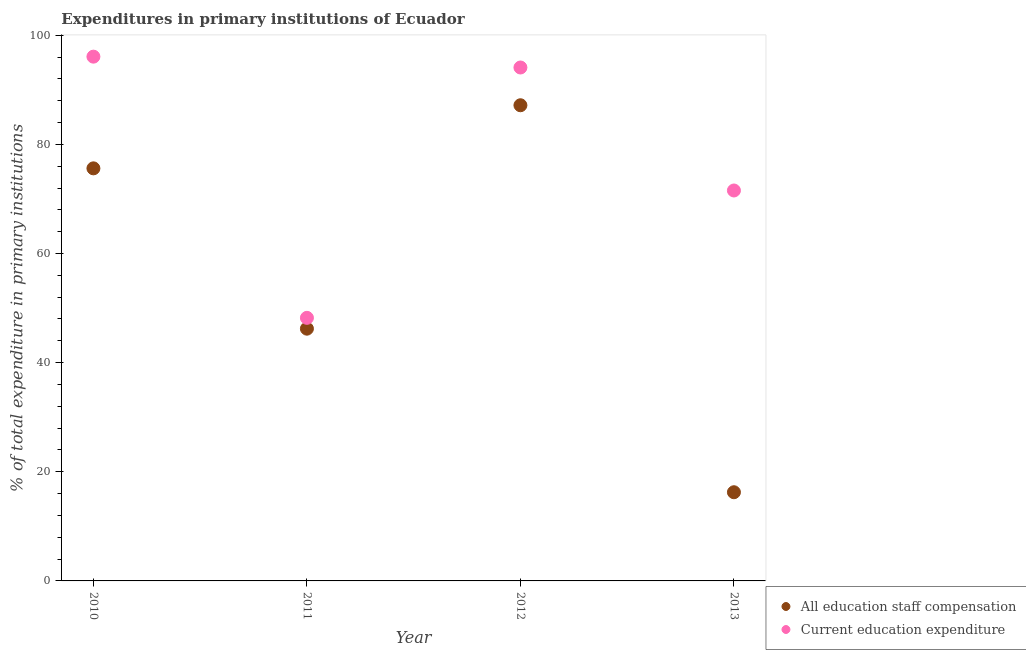How many different coloured dotlines are there?
Keep it short and to the point. 2. What is the expenditure in education in 2011?
Offer a very short reply. 48.21. Across all years, what is the maximum expenditure in education?
Your response must be concise. 96.07. Across all years, what is the minimum expenditure in staff compensation?
Offer a very short reply. 16.25. What is the total expenditure in staff compensation in the graph?
Offer a very short reply. 225.25. What is the difference between the expenditure in staff compensation in 2010 and that in 2011?
Provide a succinct answer. 29.38. What is the difference between the expenditure in staff compensation in 2011 and the expenditure in education in 2013?
Your answer should be compact. -25.32. What is the average expenditure in education per year?
Provide a short and direct response. 77.48. In the year 2013, what is the difference between the expenditure in education and expenditure in staff compensation?
Provide a short and direct response. 55.29. What is the ratio of the expenditure in staff compensation in 2010 to that in 2011?
Your answer should be very brief. 1.64. Is the difference between the expenditure in education in 2011 and 2012 greater than the difference between the expenditure in staff compensation in 2011 and 2012?
Provide a succinct answer. No. What is the difference between the highest and the second highest expenditure in staff compensation?
Ensure brevity in your answer.  11.56. What is the difference between the highest and the lowest expenditure in staff compensation?
Keep it short and to the point. 70.91. Does the expenditure in education monotonically increase over the years?
Make the answer very short. No. Is the expenditure in staff compensation strictly greater than the expenditure in education over the years?
Provide a succinct answer. No. Is the expenditure in education strictly less than the expenditure in staff compensation over the years?
Provide a succinct answer. No. How many years are there in the graph?
Keep it short and to the point. 4. What is the difference between two consecutive major ticks on the Y-axis?
Your answer should be compact. 20. Does the graph contain any zero values?
Your answer should be very brief. No. Does the graph contain grids?
Your response must be concise. No. What is the title of the graph?
Provide a succinct answer. Expenditures in primary institutions of Ecuador. Does "Age 65(female)" appear as one of the legend labels in the graph?
Your answer should be very brief. No. What is the label or title of the X-axis?
Your response must be concise. Year. What is the label or title of the Y-axis?
Your answer should be very brief. % of total expenditure in primary institutions. What is the % of total expenditure in primary institutions in All education staff compensation in 2010?
Give a very brief answer. 75.6. What is the % of total expenditure in primary institutions of Current education expenditure in 2010?
Ensure brevity in your answer.  96.07. What is the % of total expenditure in primary institutions in All education staff compensation in 2011?
Make the answer very short. 46.22. What is the % of total expenditure in primary institutions in Current education expenditure in 2011?
Give a very brief answer. 48.21. What is the % of total expenditure in primary institutions of All education staff compensation in 2012?
Give a very brief answer. 87.17. What is the % of total expenditure in primary institutions of Current education expenditure in 2012?
Provide a succinct answer. 94.08. What is the % of total expenditure in primary institutions in All education staff compensation in 2013?
Make the answer very short. 16.25. What is the % of total expenditure in primary institutions of Current education expenditure in 2013?
Provide a short and direct response. 71.55. Across all years, what is the maximum % of total expenditure in primary institutions of All education staff compensation?
Ensure brevity in your answer.  87.17. Across all years, what is the maximum % of total expenditure in primary institutions in Current education expenditure?
Your answer should be very brief. 96.07. Across all years, what is the minimum % of total expenditure in primary institutions of All education staff compensation?
Your answer should be very brief. 16.25. Across all years, what is the minimum % of total expenditure in primary institutions in Current education expenditure?
Your response must be concise. 48.21. What is the total % of total expenditure in primary institutions of All education staff compensation in the graph?
Provide a short and direct response. 225.25. What is the total % of total expenditure in primary institutions of Current education expenditure in the graph?
Ensure brevity in your answer.  309.91. What is the difference between the % of total expenditure in primary institutions of All education staff compensation in 2010 and that in 2011?
Make the answer very short. 29.38. What is the difference between the % of total expenditure in primary institutions in Current education expenditure in 2010 and that in 2011?
Your response must be concise. 47.86. What is the difference between the % of total expenditure in primary institutions of All education staff compensation in 2010 and that in 2012?
Make the answer very short. -11.56. What is the difference between the % of total expenditure in primary institutions in Current education expenditure in 2010 and that in 2012?
Your response must be concise. 1.99. What is the difference between the % of total expenditure in primary institutions in All education staff compensation in 2010 and that in 2013?
Give a very brief answer. 59.35. What is the difference between the % of total expenditure in primary institutions of Current education expenditure in 2010 and that in 2013?
Give a very brief answer. 24.52. What is the difference between the % of total expenditure in primary institutions in All education staff compensation in 2011 and that in 2012?
Make the answer very short. -40.94. What is the difference between the % of total expenditure in primary institutions in Current education expenditure in 2011 and that in 2012?
Offer a terse response. -45.87. What is the difference between the % of total expenditure in primary institutions of All education staff compensation in 2011 and that in 2013?
Offer a very short reply. 29.97. What is the difference between the % of total expenditure in primary institutions in Current education expenditure in 2011 and that in 2013?
Keep it short and to the point. -23.34. What is the difference between the % of total expenditure in primary institutions of All education staff compensation in 2012 and that in 2013?
Keep it short and to the point. 70.91. What is the difference between the % of total expenditure in primary institutions in Current education expenditure in 2012 and that in 2013?
Offer a terse response. 22.54. What is the difference between the % of total expenditure in primary institutions of All education staff compensation in 2010 and the % of total expenditure in primary institutions of Current education expenditure in 2011?
Provide a succinct answer. 27.39. What is the difference between the % of total expenditure in primary institutions in All education staff compensation in 2010 and the % of total expenditure in primary institutions in Current education expenditure in 2012?
Your answer should be compact. -18.48. What is the difference between the % of total expenditure in primary institutions of All education staff compensation in 2010 and the % of total expenditure in primary institutions of Current education expenditure in 2013?
Your answer should be compact. 4.06. What is the difference between the % of total expenditure in primary institutions of All education staff compensation in 2011 and the % of total expenditure in primary institutions of Current education expenditure in 2012?
Your response must be concise. -47.86. What is the difference between the % of total expenditure in primary institutions of All education staff compensation in 2011 and the % of total expenditure in primary institutions of Current education expenditure in 2013?
Your response must be concise. -25.32. What is the difference between the % of total expenditure in primary institutions of All education staff compensation in 2012 and the % of total expenditure in primary institutions of Current education expenditure in 2013?
Provide a short and direct response. 15.62. What is the average % of total expenditure in primary institutions in All education staff compensation per year?
Provide a short and direct response. 56.31. What is the average % of total expenditure in primary institutions in Current education expenditure per year?
Keep it short and to the point. 77.48. In the year 2010, what is the difference between the % of total expenditure in primary institutions in All education staff compensation and % of total expenditure in primary institutions in Current education expenditure?
Offer a very short reply. -20.47. In the year 2011, what is the difference between the % of total expenditure in primary institutions of All education staff compensation and % of total expenditure in primary institutions of Current education expenditure?
Keep it short and to the point. -1.99. In the year 2012, what is the difference between the % of total expenditure in primary institutions in All education staff compensation and % of total expenditure in primary institutions in Current education expenditure?
Make the answer very short. -6.92. In the year 2013, what is the difference between the % of total expenditure in primary institutions of All education staff compensation and % of total expenditure in primary institutions of Current education expenditure?
Your answer should be very brief. -55.29. What is the ratio of the % of total expenditure in primary institutions of All education staff compensation in 2010 to that in 2011?
Your answer should be compact. 1.64. What is the ratio of the % of total expenditure in primary institutions in Current education expenditure in 2010 to that in 2011?
Provide a succinct answer. 1.99. What is the ratio of the % of total expenditure in primary institutions of All education staff compensation in 2010 to that in 2012?
Keep it short and to the point. 0.87. What is the ratio of the % of total expenditure in primary institutions in Current education expenditure in 2010 to that in 2012?
Provide a short and direct response. 1.02. What is the ratio of the % of total expenditure in primary institutions in All education staff compensation in 2010 to that in 2013?
Offer a very short reply. 4.65. What is the ratio of the % of total expenditure in primary institutions in Current education expenditure in 2010 to that in 2013?
Give a very brief answer. 1.34. What is the ratio of the % of total expenditure in primary institutions of All education staff compensation in 2011 to that in 2012?
Provide a short and direct response. 0.53. What is the ratio of the % of total expenditure in primary institutions of Current education expenditure in 2011 to that in 2012?
Provide a succinct answer. 0.51. What is the ratio of the % of total expenditure in primary institutions in All education staff compensation in 2011 to that in 2013?
Ensure brevity in your answer.  2.84. What is the ratio of the % of total expenditure in primary institutions in Current education expenditure in 2011 to that in 2013?
Offer a terse response. 0.67. What is the ratio of the % of total expenditure in primary institutions of All education staff compensation in 2012 to that in 2013?
Offer a terse response. 5.36. What is the ratio of the % of total expenditure in primary institutions of Current education expenditure in 2012 to that in 2013?
Offer a terse response. 1.31. What is the difference between the highest and the second highest % of total expenditure in primary institutions of All education staff compensation?
Your answer should be very brief. 11.56. What is the difference between the highest and the second highest % of total expenditure in primary institutions of Current education expenditure?
Offer a terse response. 1.99. What is the difference between the highest and the lowest % of total expenditure in primary institutions of All education staff compensation?
Keep it short and to the point. 70.91. What is the difference between the highest and the lowest % of total expenditure in primary institutions of Current education expenditure?
Provide a succinct answer. 47.86. 